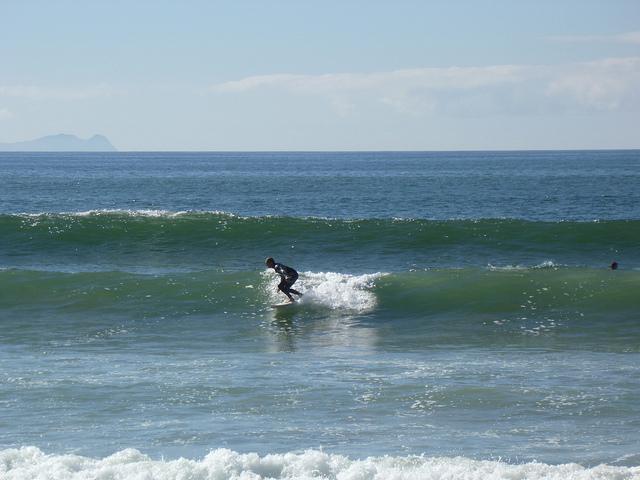What is a term related to this event?
Pick the right solution, then justify: 'Answer: answer
Rationale: rationale.'
Options: Goal, homerun, surfs up, balance beam. Answer: surfs up.
Rationale: The man is surfing in the water. 